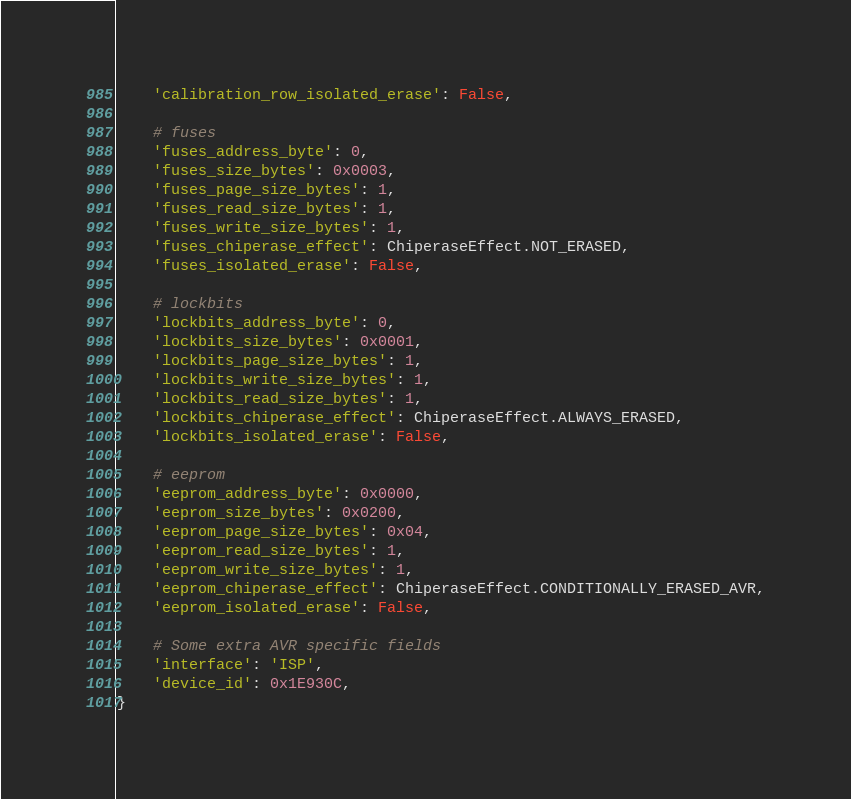<code> <loc_0><loc_0><loc_500><loc_500><_Python_>    'calibration_row_isolated_erase': False,

    # fuses
    'fuses_address_byte': 0,
    'fuses_size_bytes': 0x0003,
    'fuses_page_size_bytes': 1,
    'fuses_read_size_bytes': 1,
    'fuses_write_size_bytes': 1,
    'fuses_chiperase_effect': ChiperaseEffect.NOT_ERASED,
    'fuses_isolated_erase': False,

    # lockbits
    'lockbits_address_byte': 0,
    'lockbits_size_bytes': 0x0001,
    'lockbits_page_size_bytes': 1,
    'lockbits_write_size_bytes': 1,
    'lockbits_read_size_bytes': 1,
    'lockbits_chiperase_effect': ChiperaseEffect.ALWAYS_ERASED,
    'lockbits_isolated_erase': False,

    # eeprom
    'eeprom_address_byte': 0x0000,
    'eeprom_size_bytes': 0x0200,
    'eeprom_page_size_bytes': 0x04,
    'eeprom_read_size_bytes': 1,
    'eeprom_write_size_bytes': 1,
    'eeprom_chiperase_effect': ChiperaseEffect.CONDITIONALLY_ERASED_AVR,
    'eeprom_isolated_erase': False,

    # Some extra AVR specific fields
    'interface': 'ISP',
    'device_id': 0x1E930C,
}
</code> 